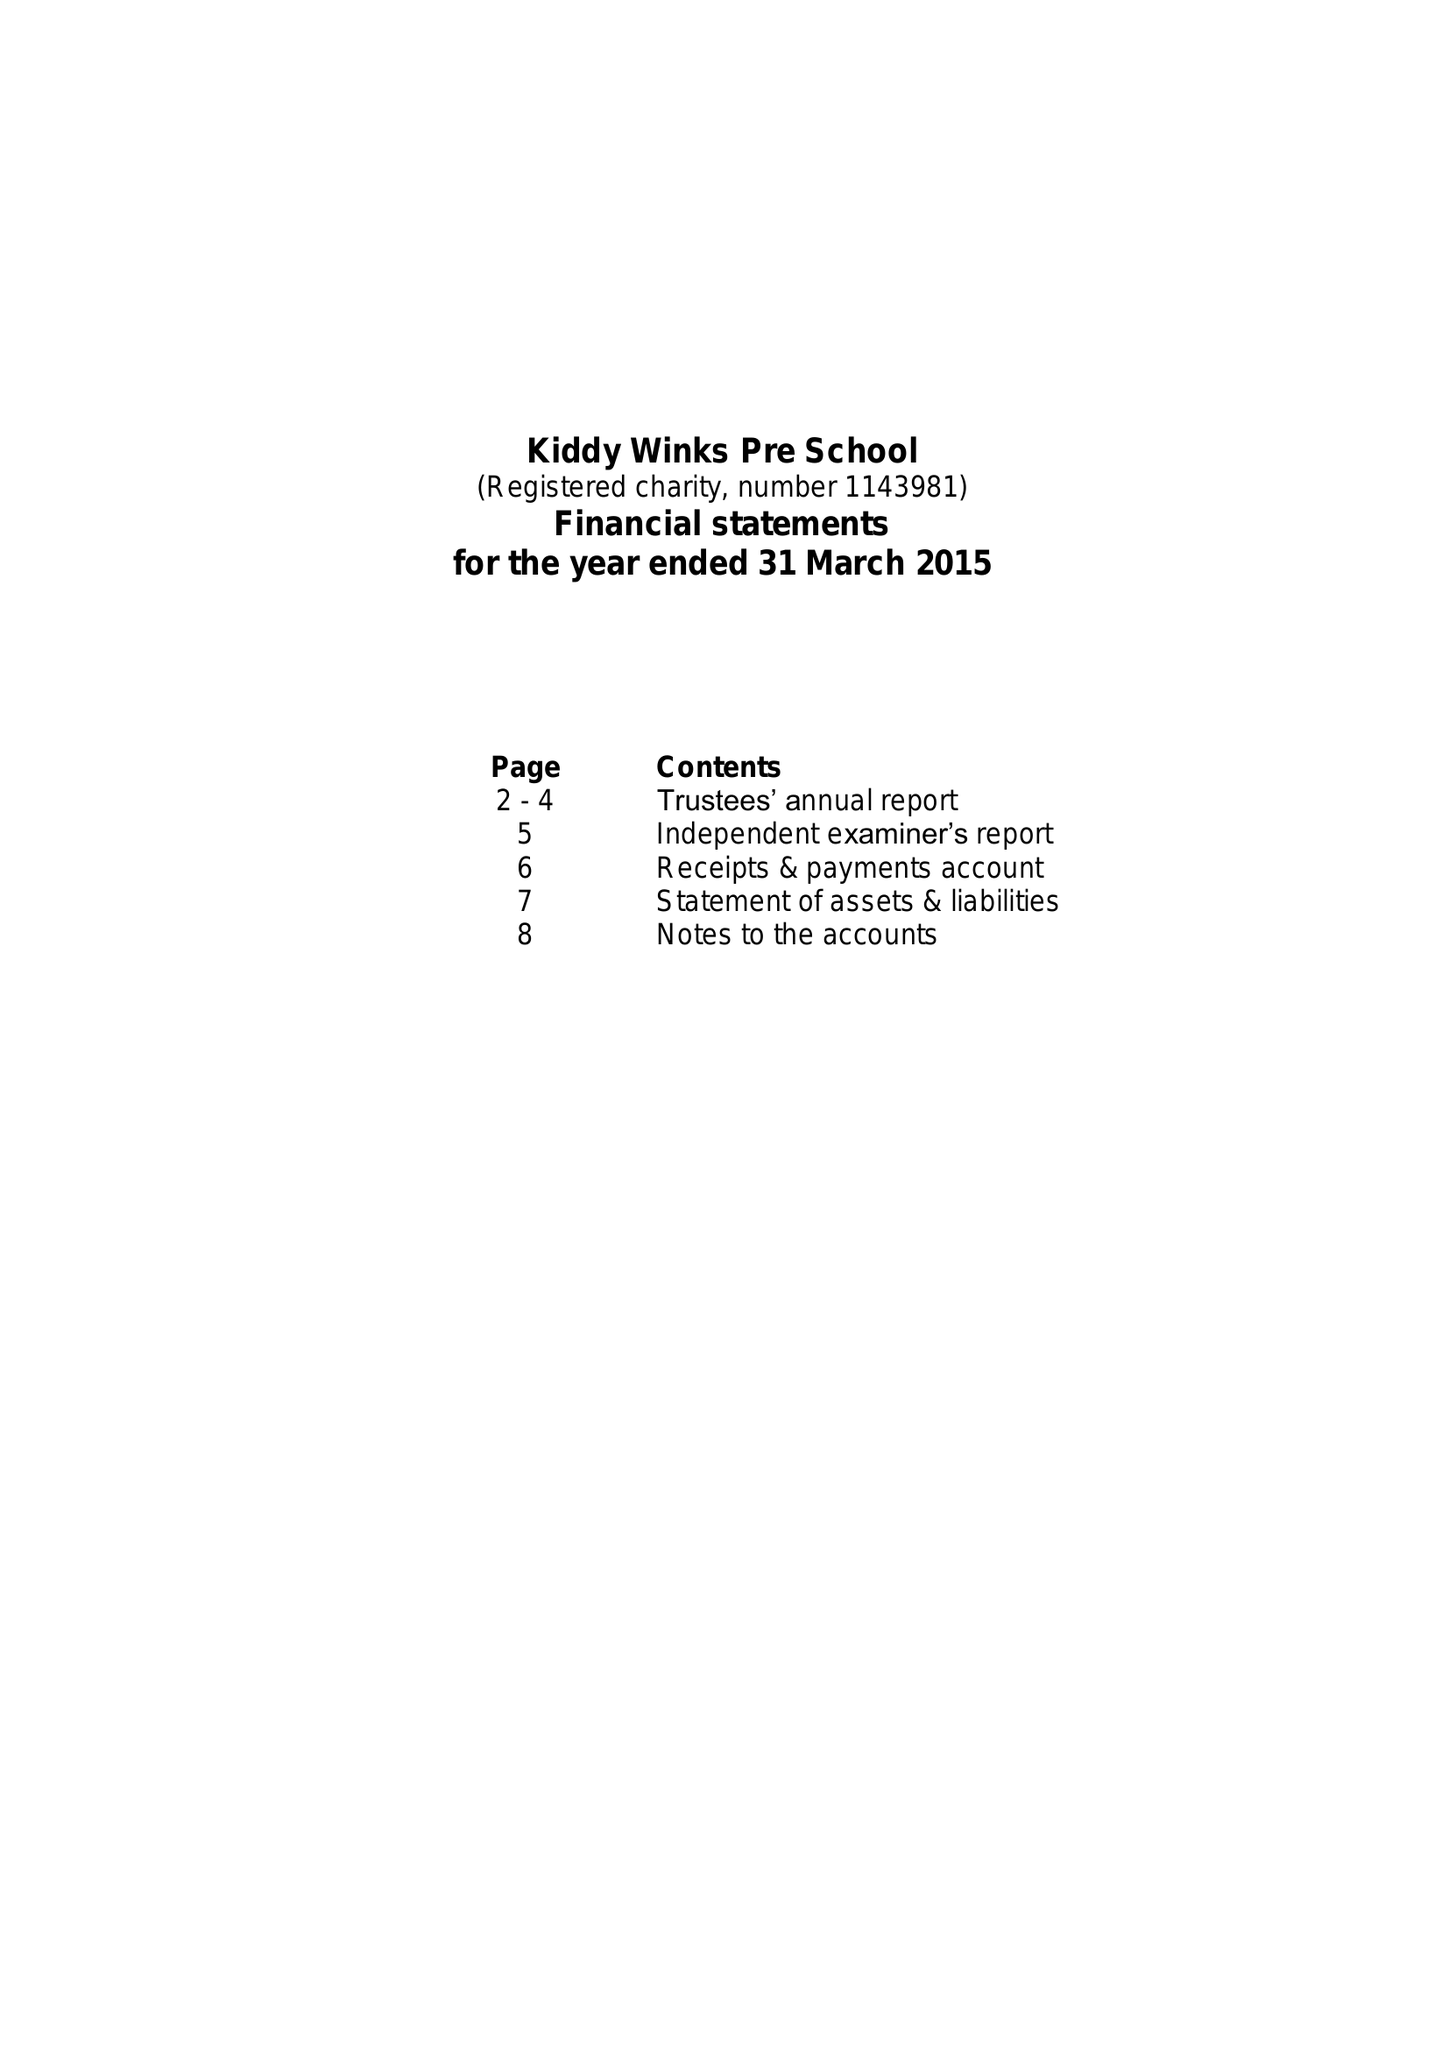What is the value for the charity_name?
Answer the question using a single word or phrase. Kiddy Winks Pre School 